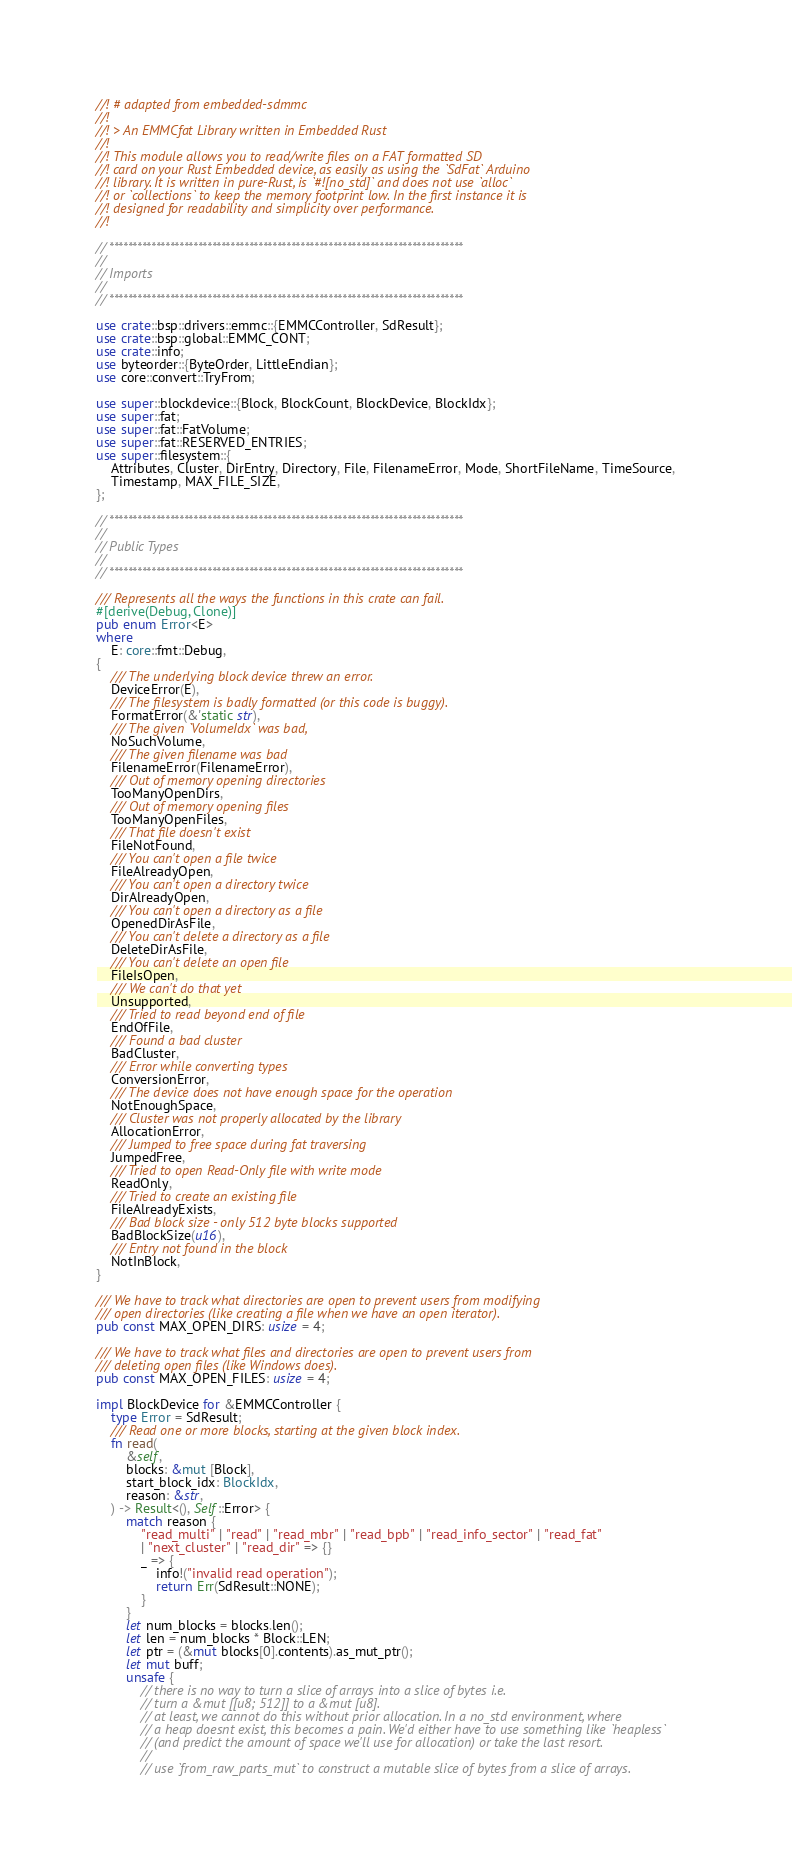<code> <loc_0><loc_0><loc_500><loc_500><_Rust_>//! # adapted from embedded-sdmmc
//!
//! > An EMMCfat Library written in Embedded Rust
//!
//! This module allows you to read/write files on a FAT formatted SD
//! card on your Rust Embedded device, as easily as using the `SdFat` Arduino
//! library. It is written in pure-Rust, is `#![no_std]` and does not use `alloc`
//! or `collections` to keep the memory footprint low. In the first instance it is
//! designed for readability and simplicity over performance.
//!

// ****************************************************************************
//
// Imports
//
// ****************************************************************************

use crate::bsp::drivers::emmc::{EMMCController, SdResult};
use crate::bsp::global::EMMC_CONT;
use crate::info;
use byteorder::{ByteOrder, LittleEndian};
use core::convert::TryFrom;

use super::blockdevice::{Block, BlockCount, BlockDevice, BlockIdx};
use super::fat;
use super::fat::FatVolume;
use super::fat::RESERVED_ENTRIES;
use super::filesystem::{
    Attributes, Cluster, DirEntry, Directory, File, FilenameError, Mode, ShortFileName, TimeSource,
    Timestamp, MAX_FILE_SIZE,
};

// ****************************************************************************
//
// Public Types
//
// ****************************************************************************

/// Represents all the ways the functions in this crate can fail.
#[derive(Debug, Clone)]
pub enum Error<E>
where
    E: core::fmt::Debug,
{
    /// The underlying block device threw an error.
    DeviceError(E),
    /// The filesystem is badly formatted (or this code is buggy).
    FormatError(&'static str),
    /// The given `VolumeIdx` was bad,
    NoSuchVolume,
    /// The given filename was bad
    FilenameError(FilenameError),
    /// Out of memory opening directories
    TooManyOpenDirs,
    /// Out of memory opening files
    TooManyOpenFiles,
    /// That file doesn't exist
    FileNotFound,
    /// You can't open a file twice
    FileAlreadyOpen,
    /// You can't open a directory twice
    DirAlreadyOpen,
    /// You can't open a directory as a file
    OpenedDirAsFile,
    /// You can't delete a directory as a file
    DeleteDirAsFile,
    /// You can't delete an open file
    FileIsOpen,
    /// We can't do that yet
    Unsupported,
    /// Tried to read beyond end of file
    EndOfFile,
    /// Found a bad cluster
    BadCluster,
    /// Error while converting types
    ConversionError,
    /// The device does not have enough space for the operation
    NotEnoughSpace,
    /// Cluster was not properly allocated by the library
    AllocationError,
    /// Jumped to free space during fat traversing
    JumpedFree,
    /// Tried to open Read-Only file with write mode
    ReadOnly,
    /// Tried to create an existing file
    FileAlreadyExists,
    /// Bad block size - only 512 byte blocks supported
    BadBlockSize(u16),
    /// Entry not found in the block
    NotInBlock,
}

/// We have to track what directories are open to prevent users from modifying
/// open directories (like creating a file when we have an open iterator).
pub const MAX_OPEN_DIRS: usize = 4;

/// We have to track what files and directories are open to prevent users from
/// deleting open files (like Windows does).
pub const MAX_OPEN_FILES: usize = 4;

impl BlockDevice for &EMMCController {
    type Error = SdResult;
    /// Read one or more blocks, starting at the given block index.
    fn read(
        &self,
        blocks: &mut [Block],
        start_block_idx: BlockIdx,
        reason: &str,
    ) -> Result<(), Self::Error> {
        match reason {
            "read_multi" | "read" | "read_mbr" | "read_bpb" | "read_info_sector" | "read_fat"
            | "next_cluster" | "read_dir" => {}
            _ => {
                info!("invalid read operation");
                return Err(SdResult::NONE);
            }
        }
        let num_blocks = blocks.len();
        let len = num_blocks * Block::LEN;
        let ptr = (&mut blocks[0].contents).as_mut_ptr();
        let mut buff;
        unsafe {
            // there is no way to turn a slice of arrays into a slice of bytes i.e.
            // turn a &mut [[u8; 512]] to a &mut [u8].
            // at least, we cannot do this without prior allocation. In a no_std environment, where
            // a heap doesnt exist, this becomes a pain. We'd either have to use something like `heapless`
            // (and predict the amount of space we'll use for allocation) or take the last resort.
            //
            // use `from_raw_parts_mut` to construct a mutable slice of bytes from a slice of arrays.</code> 